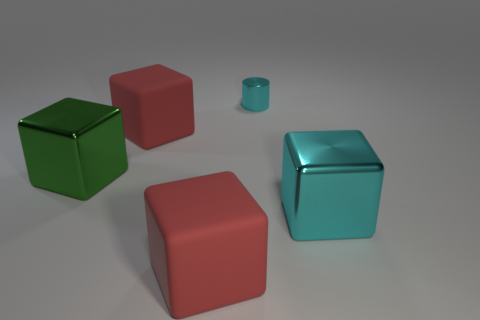What function might these objects serve? These objects appear to be 3D models and could serve as visual assets in a digital environment, such as a video game or a simulation, or perhaps be used for graphical design purposes. 